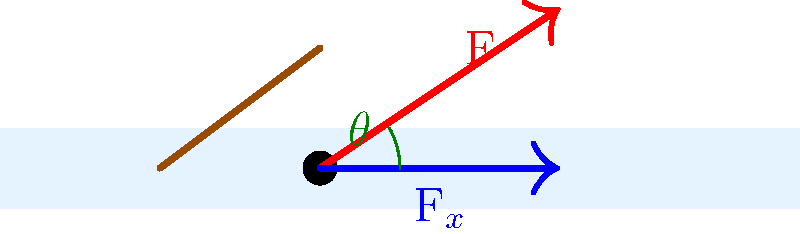As a sports radio host discussing the Arizona State Sun Devils men's ice hockey team, you want to explain the biomechanics of a slapshot to your listeners. Given that the force applied to the puck during a slapshot can be represented by the red vector F in the diagram, what is the optimal angle $\theta$ for maximizing the horizontal component of the force (F$_x$) and, consequently, the speed of the puck? To find the optimal angle for a slapshot, we need to maximize the horizontal component of the force (F$_x$). Let's break this down step-by-step:

1. The horizontal component of the force is given by:
   $$F_x = F \cos(\theta)$$
   where F is the magnitude of the total force and $\theta$ is the angle from the horizontal.

2. To maximize F$_x$, we need to maximize $\cos(\theta)$.

3. The cosine function reaches its maximum value of 1 when its argument is 0°.

4. Therefore, the horizontal component F$_x$ will be maximized when $\theta = 0°$.

5. This means that the optimal angle for a slapshot, from a purely biomechanical perspective, is 0° relative to the ice surface.

6. At this angle, all of the force is directed horizontally, maximizing the speed of the puck across the ice.

7. In practice, players often use a slight upward angle to lift the puck off the ice, but for maximum speed, a 0° angle is theoretically optimal.

It's worth noting that in real gameplay, factors such as puck elevation, obstacles (like other players), and the need to shoot over the goalie's pads might necessitate a non-zero angle. However, for pure speed and distance, a 0° angle is ideal.
Answer: 0° 